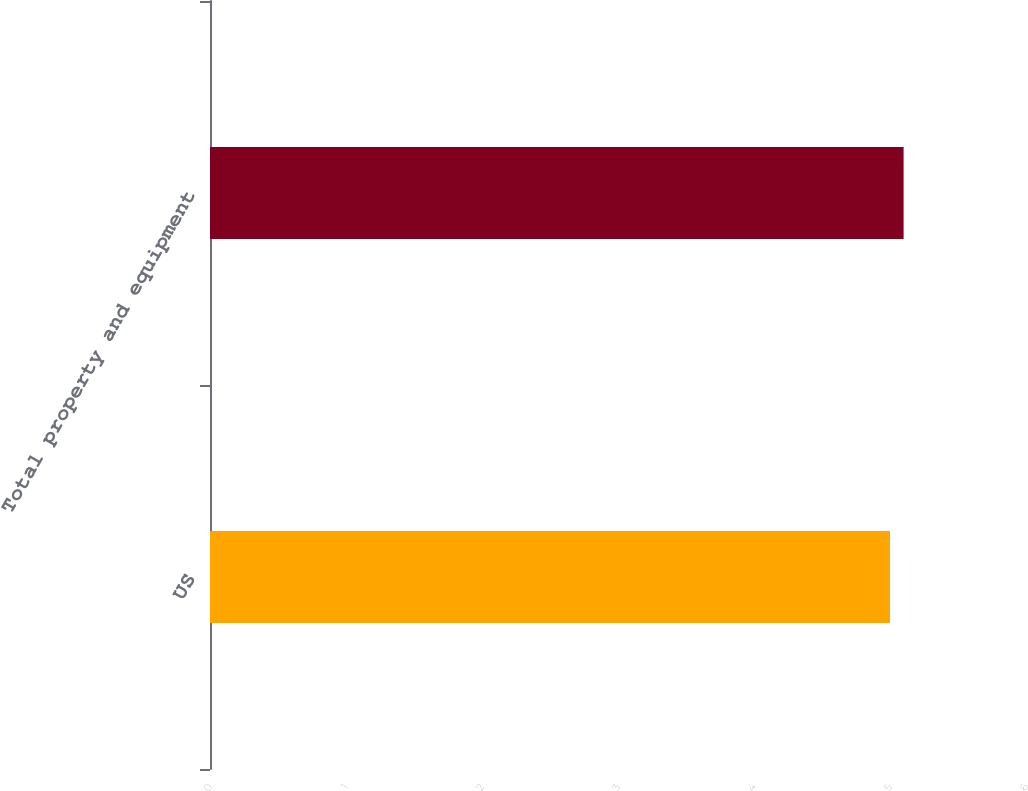Convert chart. <chart><loc_0><loc_0><loc_500><loc_500><bar_chart><fcel>US<fcel>Total property and equipment<nl><fcel>5<fcel>5.1<nl></chart> 